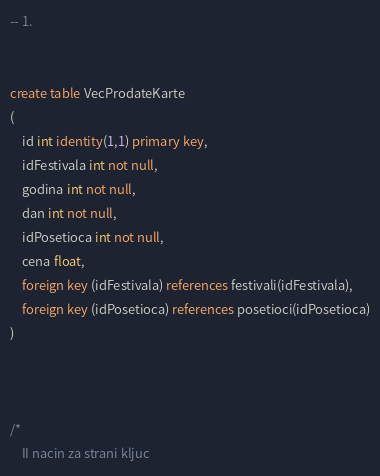Convert code to text. <code><loc_0><loc_0><loc_500><loc_500><_SQL_>
-- 1.


create table VecProdateKarte
(
	id int identity(1,1) primary key,
	idFestivala int not null,
	godina int not null,
	dan int not null,
	idPosetioca int not null,
	cena float,
	foreign key (idFestivala) references festivali(idFestivala),
	foreign key (idPosetioca) references posetioci(idPosetioca)
)



/*
	II nacin za strani kljuc
</code> 